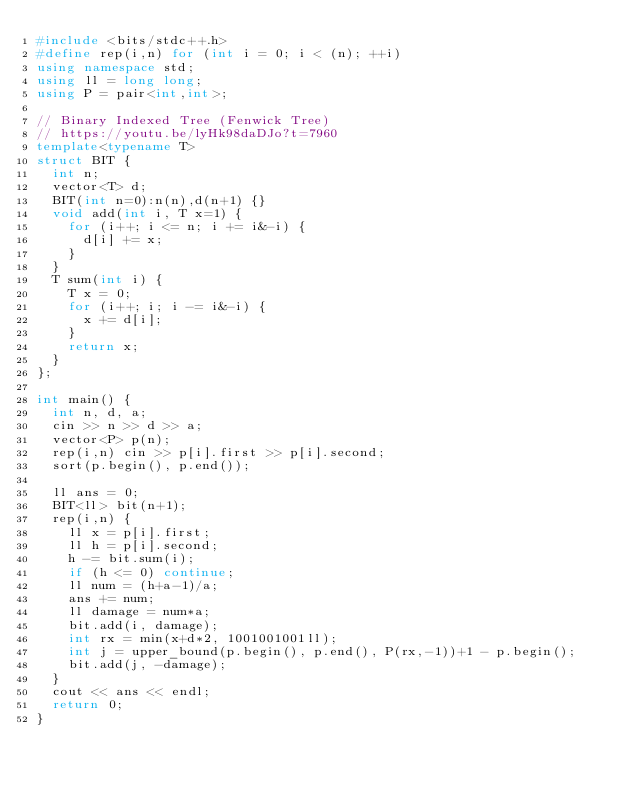Convert code to text. <code><loc_0><loc_0><loc_500><loc_500><_C++_>#include <bits/stdc++.h>
#define rep(i,n) for (int i = 0; i < (n); ++i)
using namespace std;
using ll = long long;
using P = pair<int,int>;
 
// Binary Indexed Tree (Fenwick Tree)
// https://youtu.be/lyHk98daDJo?t=7960
template<typename T>
struct BIT {
  int n;
  vector<T> d;
  BIT(int n=0):n(n),d(n+1) {}
  void add(int i, T x=1) {
    for (i++; i <= n; i += i&-i) {
      d[i] += x;
    }
  }
  T sum(int i) {
    T x = 0;
    for (i++; i; i -= i&-i) {
      x += d[i];
    }
    return x;
  }
};
 
int main() {
  int n, d, a;
  cin >> n >> d >> a;
  vector<P> p(n);
  rep(i,n) cin >> p[i].first >> p[i].second;
  sort(p.begin(), p.end());
 
  ll ans = 0;
  BIT<ll> bit(n+1);
  rep(i,n) {
    ll x = p[i].first;
    ll h = p[i].second;
    h -= bit.sum(i);
    if (h <= 0) continue;
    ll num = (h+a-1)/a;
    ans += num;
    ll damage = num*a;
    bit.add(i, damage);
    int rx = min(x+d*2, 1001001001ll);
    int j = upper_bound(p.begin(), p.end(), P(rx,-1))+1 - p.begin();
    bit.add(j, -damage);
  }
  cout << ans << endl;
  return 0;
}
</code> 